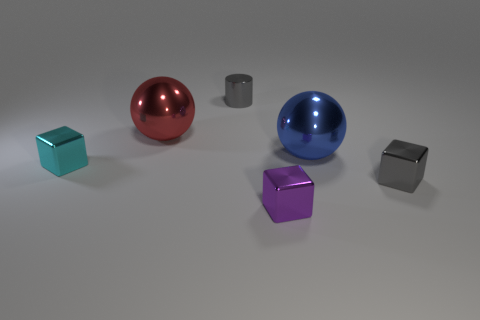The blue metallic object is what size?
Your answer should be very brief. Large. Is there a metal block of the same color as the metallic cylinder?
Ensure brevity in your answer.  Yes. There is another ball that is the same size as the blue shiny sphere; what is its color?
Provide a short and direct response. Red. There is a tiny thing that is to the right of the blue metallic object; is its color the same as the cylinder?
Provide a short and direct response. Yes. Are there any other small cylinders made of the same material as the tiny cylinder?
Make the answer very short. No. Is the number of small cyan cubes that are on the left side of the small cyan shiny object less than the number of gray rubber balls?
Give a very brief answer. No. There is a metallic ball in front of the red shiny sphere; does it have the same size as the big red shiny thing?
Your answer should be compact. Yes. How many gray objects are the same shape as the big red metal thing?
Your response must be concise. 0. What is the size of the blue sphere that is made of the same material as the cylinder?
Your response must be concise. Large. Are there an equal number of small purple cubes in front of the large blue sphere and cyan blocks?
Give a very brief answer. Yes. 